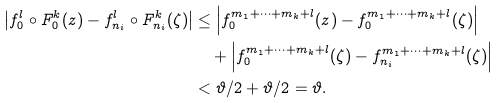Convert formula to latex. <formula><loc_0><loc_0><loc_500><loc_500>\left | f _ { 0 } ^ { l } \circ F _ { 0 } ^ { k } ( z ) - f _ { n _ { i } } ^ { l } \circ F _ { n _ { i } } ^ { k } ( \zeta ) \right | & \leq \left | f _ { 0 } ^ { m _ { 1 } + \dots + m _ { k } + l } ( z ) - f _ { 0 } ^ { m _ { 1 } + \dots + m _ { k } + l } ( \zeta ) \right | \\ & \quad + \left | f _ { 0 } ^ { m _ { 1 } + \dots + m _ { k } + l } ( \zeta ) - f _ { n _ { i } } ^ { m _ { 1 } + \dots + m _ { k } + l } ( \zeta ) \right | \\ & < \vartheta / 2 + \vartheta / 2 = \vartheta .</formula> 